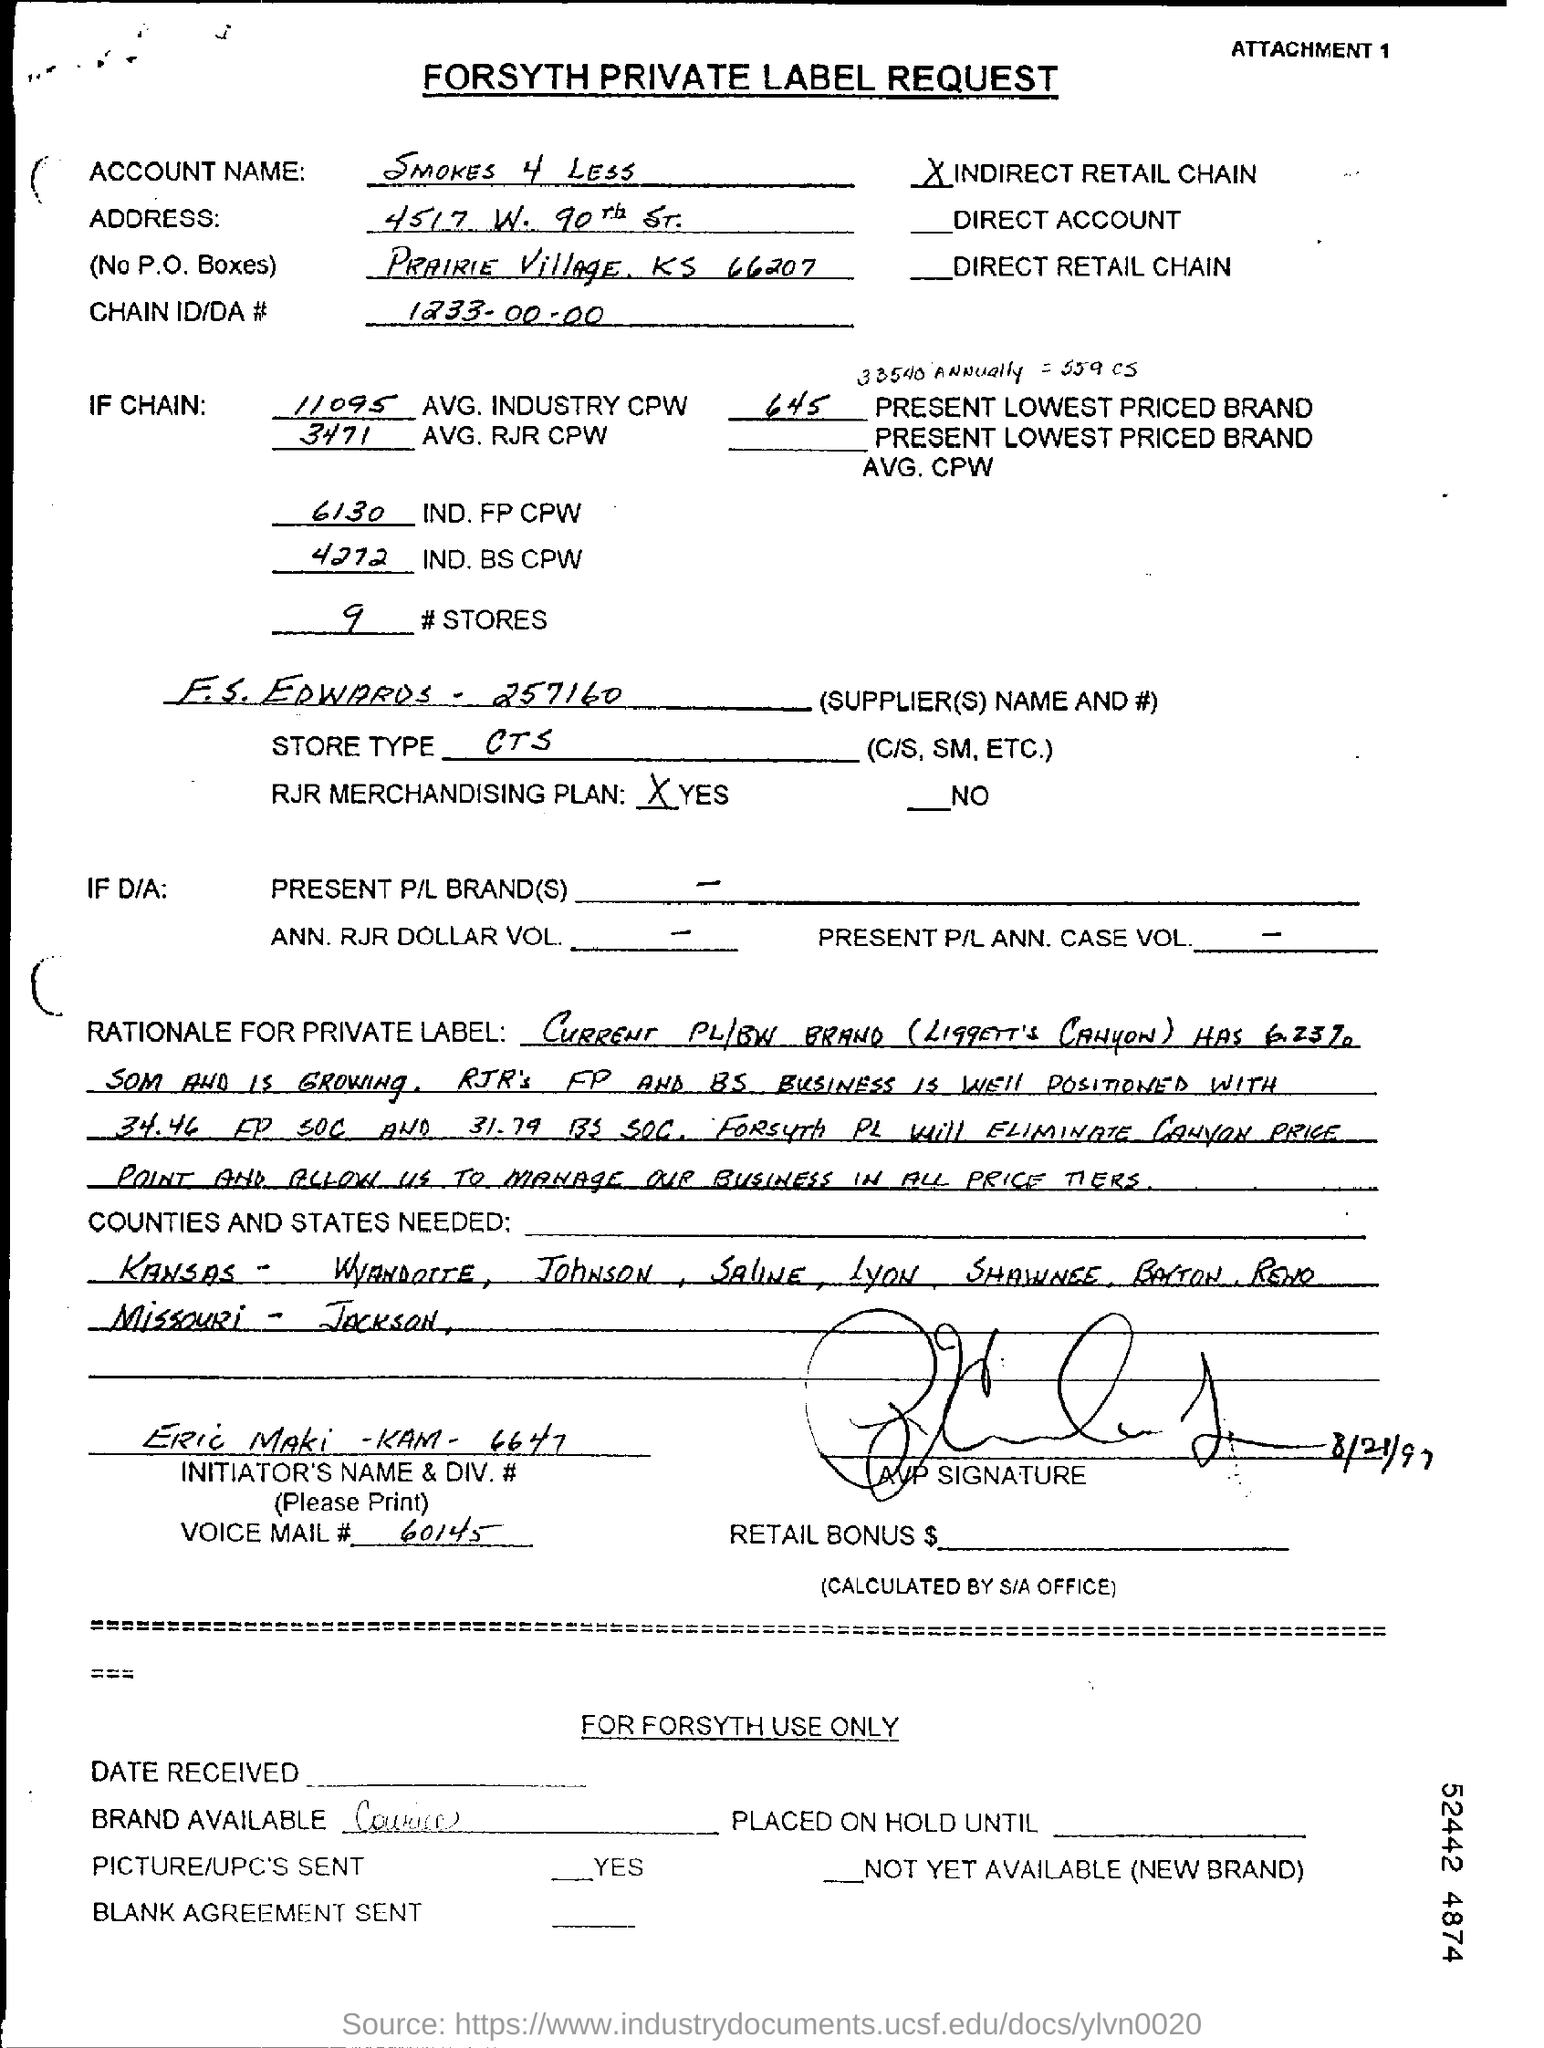Mention a couple of crucial points in this snapshot. The supplier's name is F.S. EDWARDS. The type of store mentioned in the form is CTS. 